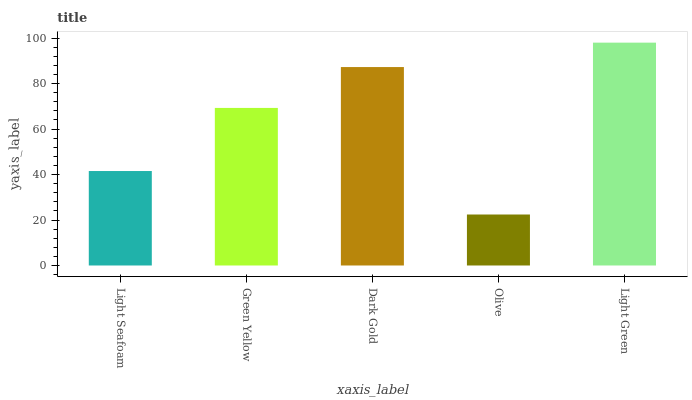Is Olive the minimum?
Answer yes or no. Yes. Is Light Green the maximum?
Answer yes or no. Yes. Is Green Yellow the minimum?
Answer yes or no. No. Is Green Yellow the maximum?
Answer yes or no. No. Is Green Yellow greater than Light Seafoam?
Answer yes or no. Yes. Is Light Seafoam less than Green Yellow?
Answer yes or no. Yes. Is Light Seafoam greater than Green Yellow?
Answer yes or no. No. Is Green Yellow less than Light Seafoam?
Answer yes or no. No. Is Green Yellow the high median?
Answer yes or no. Yes. Is Green Yellow the low median?
Answer yes or no. Yes. Is Light Green the high median?
Answer yes or no. No. Is Light Seafoam the low median?
Answer yes or no. No. 